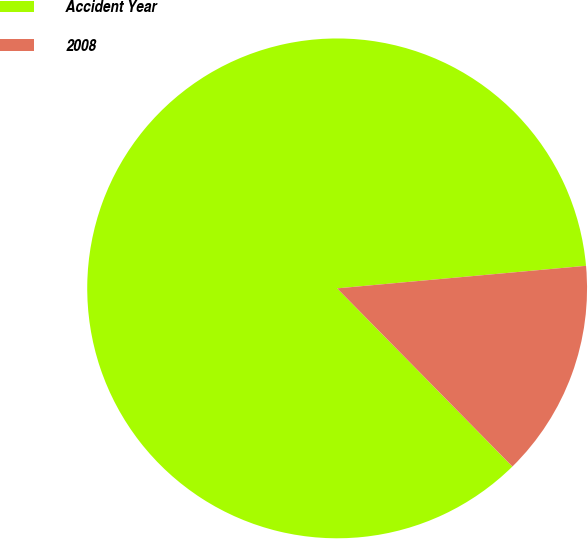Convert chart to OTSL. <chart><loc_0><loc_0><loc_500><loc_500><pie_chart><fcel>Accident Year<fcel>2008<nl><fcel>85.93%<fcel>14.07%<nl></chart> 